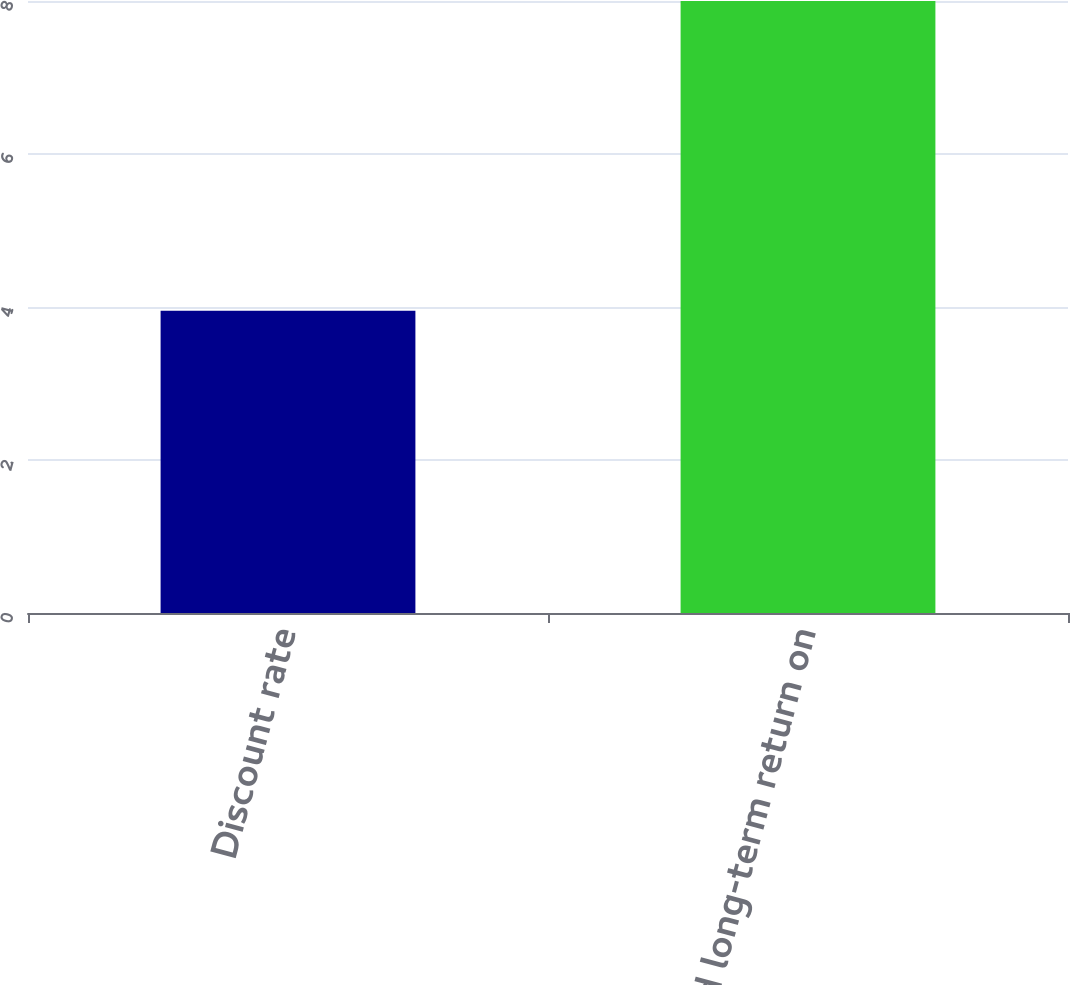Convert chart. <chart><loc_0><loc_0><loc_500><loc_500><bar_chart><fcel>Discount rate<fcel>Expected long-term return on<nl><fcel>3.95<fcel>8<nl></chart> 